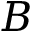Convert formula to latex. <formula><loc_0><loc_0><loc_500><loc_500>B</formula> 